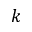Convert formula to latex. <formula><loc_0><loc_0><loc_500><loc_500>k</formula> 